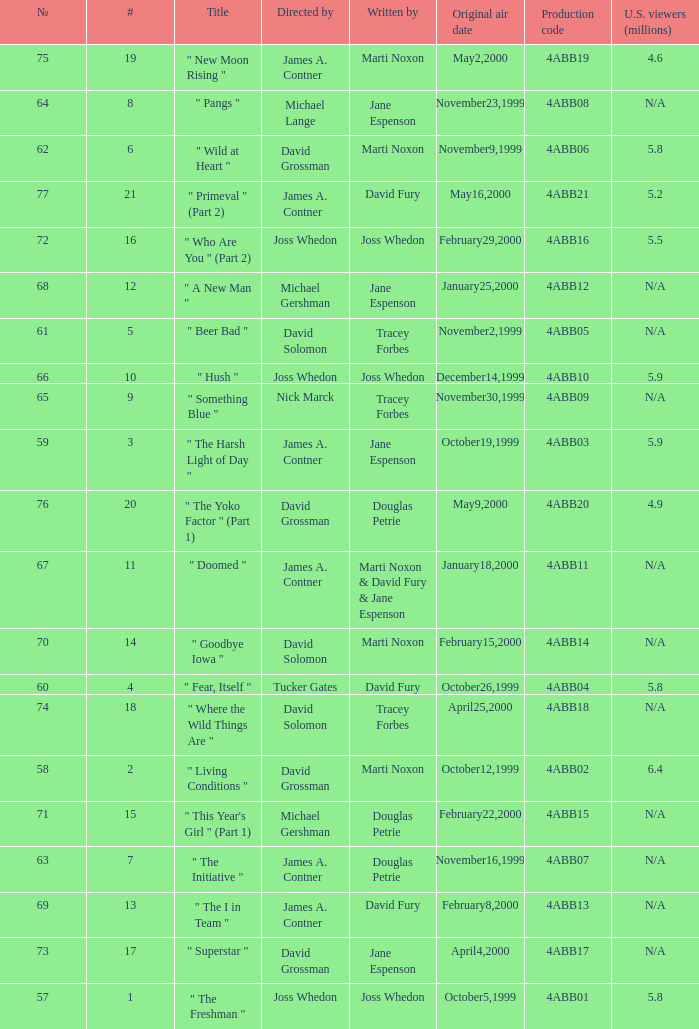What is the series No when the season 4 # is 18? 74.0. 